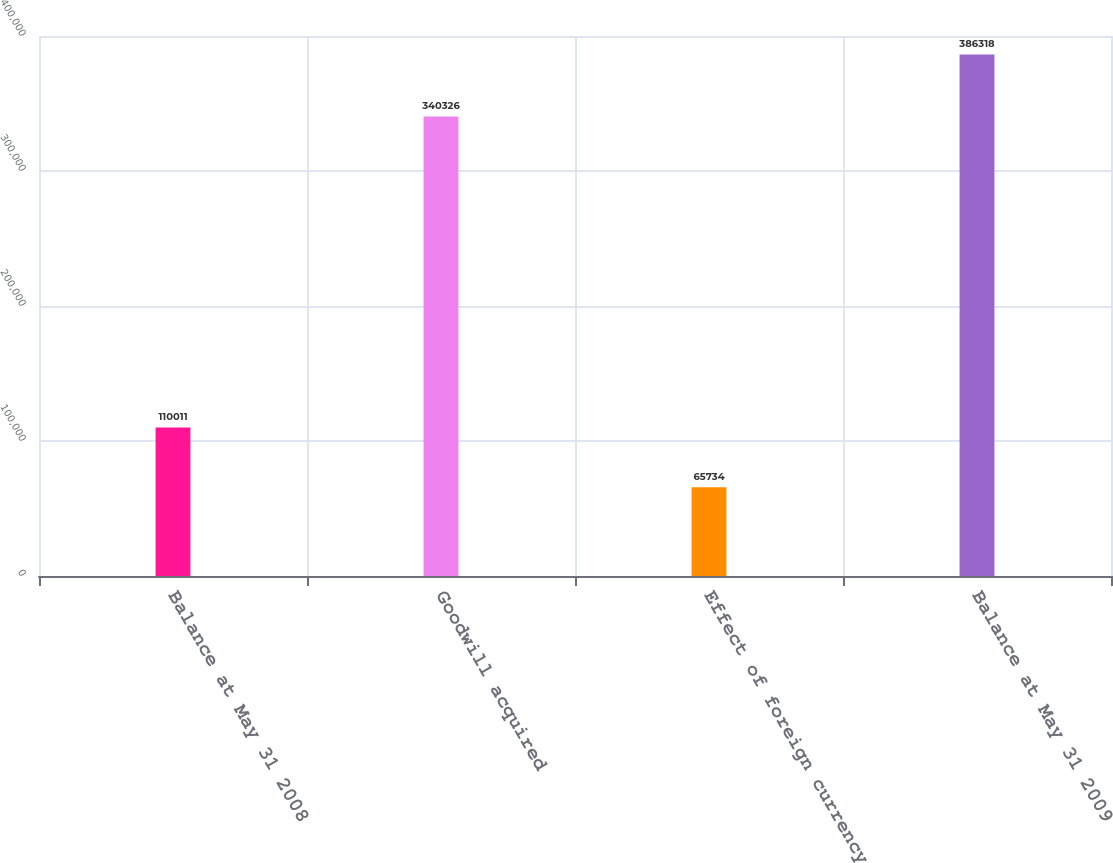Convert chart. <chart><loc_0><loc_0><loc_500><loc_500><bar_chart><fcel>Balance at May 31 2008<fcel>Goodwill acquired<fcel>Effect of foreign currency<fcel>Balance at May 31 2009<nl><fcel>110011<fcel>340326<fcel>65734<fcel>386318<nl></chart> 